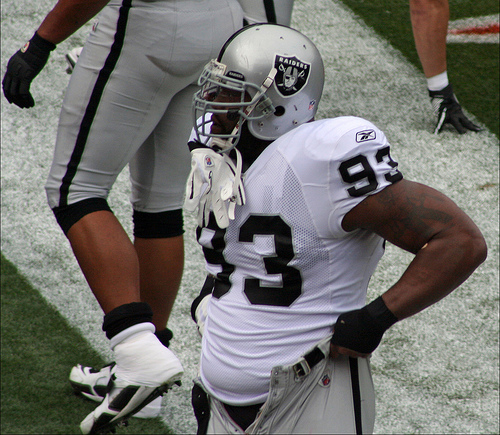<image>
Can you confirm if the butt is on the head? No. The butt is not positioned on the head. They may be near each other, but the butt is not supported by or resting on top of the head. 